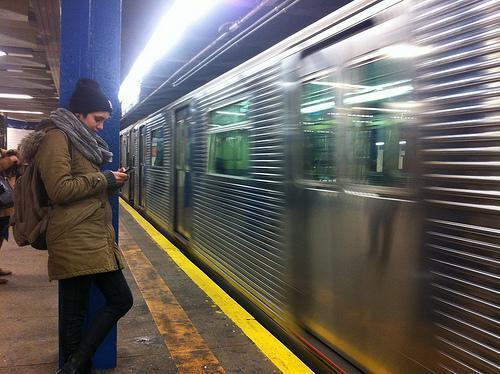How many people are there?
Give a very brief answer. 1. 